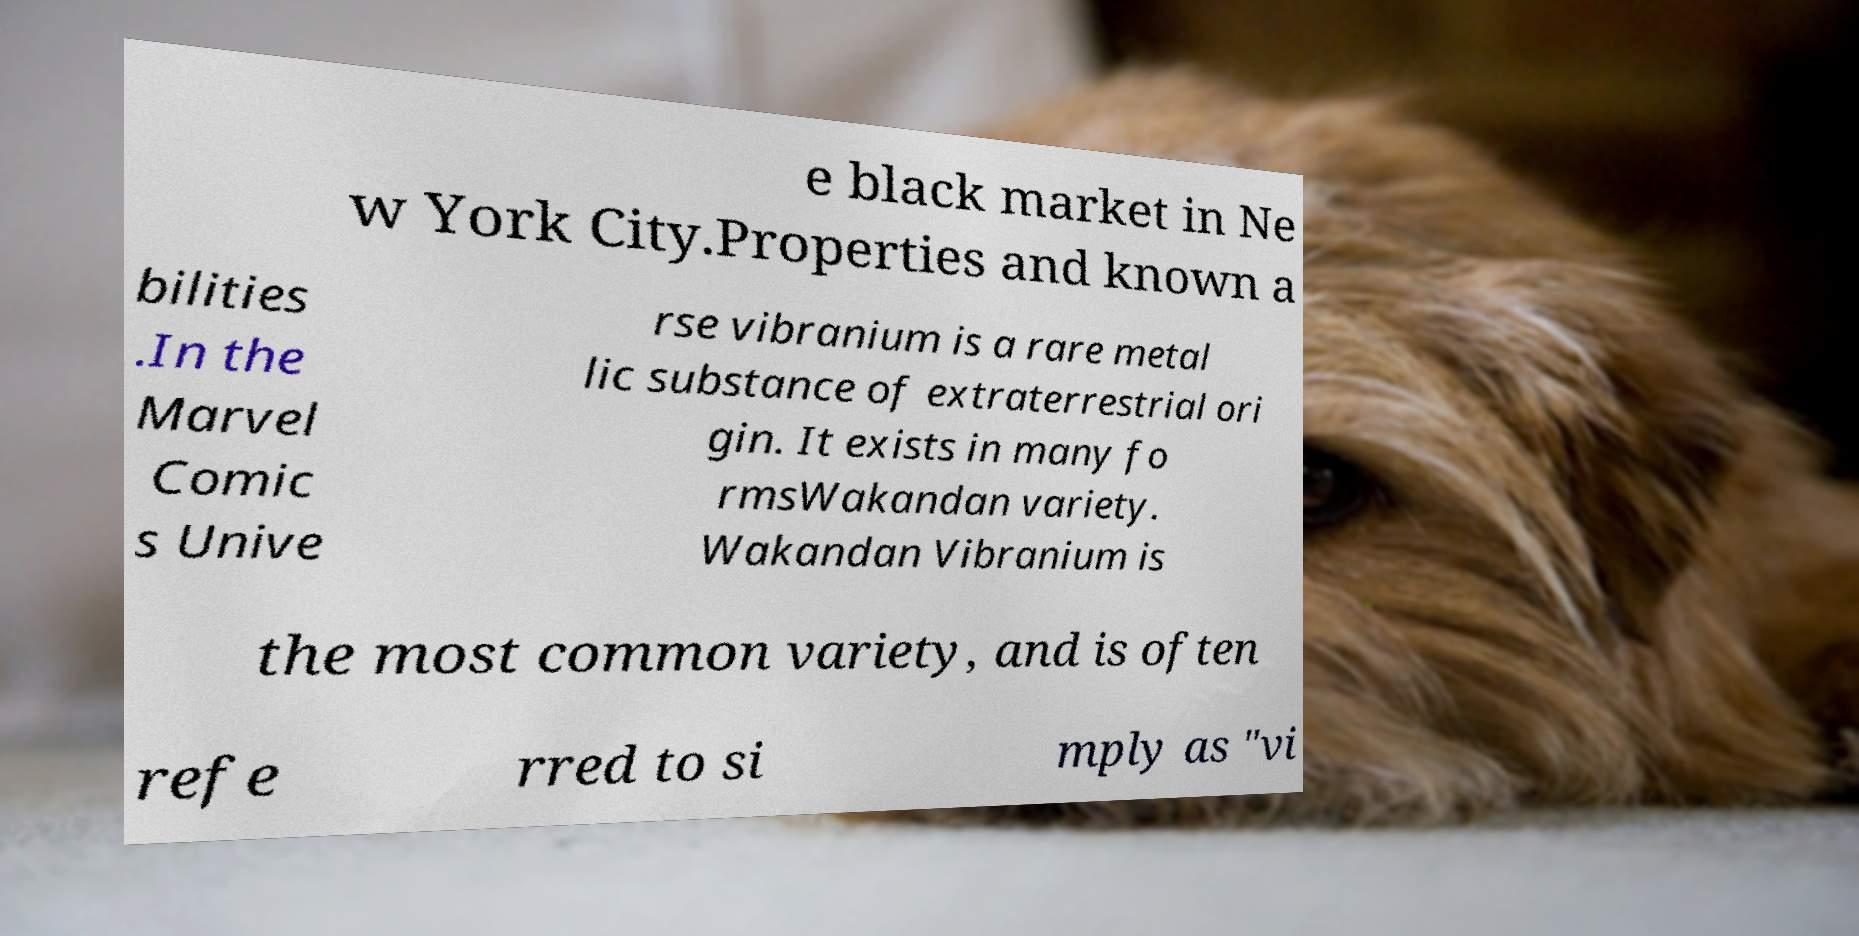Please read and relay the text visible in this image. What does it say? e black market in Ne w York City.Properties and known a bilities .In the Marvel Comic s Unive rse vibranium is a rare metal lic substance of extraterrestrial ori gin. It exists in many fo rmsWakandan variety. Wakandan Vibranium is the most common variety, and is often refe rred to si mply as "vi 